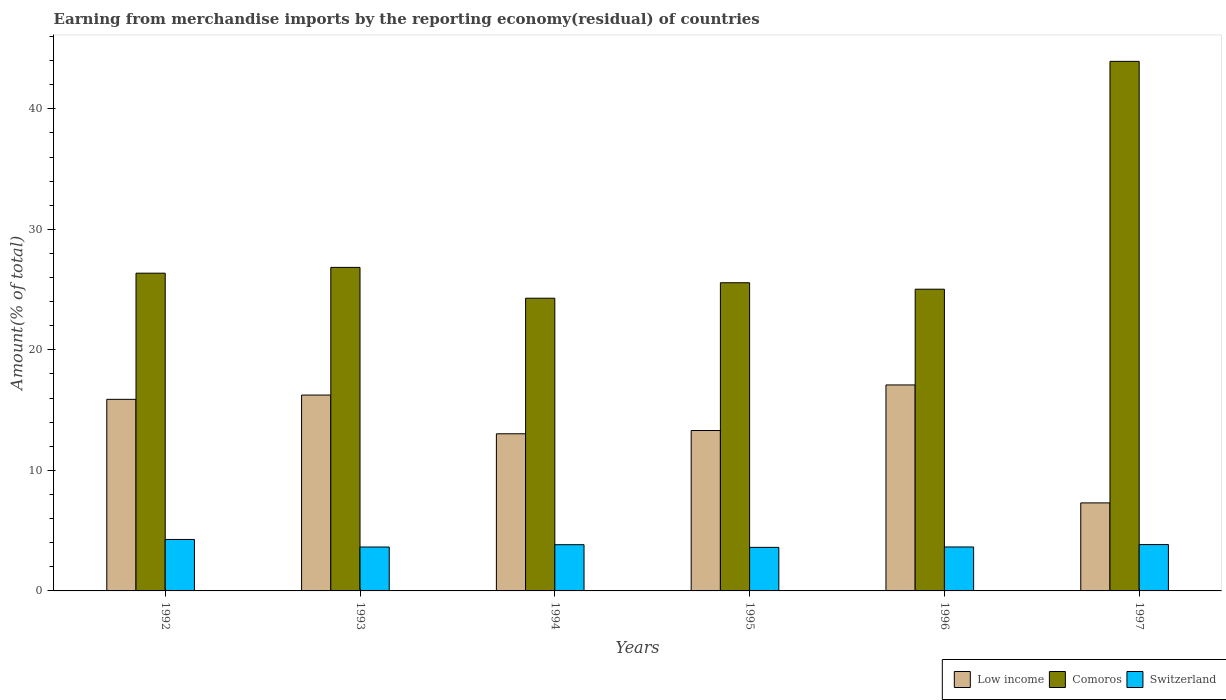Are the number of bars per tick equal to the number of legend labels?
Your answer should be compact. Yes. Are the number of bars on each tick of the X-axis equal?
Your answer should be compact. Yes. How many bars are there on the 2nd tick from the right?
Give a very brief answer. 3. In how many cases, is the number of bars for a given year not equal to the number of legend labels?
Your answer should be very brief. 0. What is the percentage of amount earned from merchandise imports in Switzerland in 1997?
Provide a succinct answer. 3.85. Across all years, what is the maximum percentage of amount earned from merchandise imports in Comoros?
Give a very brief answer. 43.94. Across all years, what is the minimum percentage of amount earned from merchandise imports in Comoros?
Your answer should be very brief. 24.29. In which year was the percentage of amount earned from merchandise imports in Low income minimum?
Provide a succinct answer. 1997. What is the total percentage of amount earned from merchandise imports in Switzerland in the graph?
Your answer should be compact. 22.86. What is the difference between the percentage of amount earned from merchandise imports in Switzerland in 1993 and that in 1995?
Your answer should be compact. 0.03. What is the difference between the percentage of amount earned from merchandise imports in Low income in 1993 and the percentage of amount earned from merchandise imports in Comoros in 1995?
Your answer should be very brief. -9.32. What is the average percentage of amount earned from merchandise imports in Low income per year?
Offer a very short reply. 13.81. In the year 1997, what is the difference between the percentage of amount earned from merchandise imports in Comoros and percentage of amount earned from merchandise imports in Switzerland?
Offer a terse response. 40.09. In how many years, is the percentage of amount earned from merchandise imports in Comoros greater than 34 %?
Your answer should be very brief. 1. What is the ratio of the percentage of amount earned from merchandise imports in Low income in 1996 to that in 1997?
Your answer should be very brief. 2.34. Is the difference between the percentage of amount earned from merchandise imports in Comoros in 1993 and 1997 greater than the difference between the percentage of amount earned from merchandise imports in Switzerland in 1993 and 1997?
Ensure brevity in your answer.  No. What is the difference between the highest and the second highest percentage of amount earned from merchandise imports in Low income?
Offer a terse response. 0.84. What is the difference between the highest and the lowest percentage of amount earned from merchandise imports in Comoros?
Make the answer very short. 19.65. In how many years, is the percentage of amount earned from merchandise imports in Comoros greater than the average percentage of amount earned from merchandise imports in Comoros taken over all years?
Make the answer very short. 1. What does the 2nd bar from the left in 1996 represents?
Give a very brief answer. Comoros. What does the 1st bar from the right in 1992 represents?
Your answer should be very brief. Switzerland. What is the difference between two consecutive major ticks on the Y-axis?
Offer a very short reply. 10. Does the graph contain any zero values?
Your response must be concise. No. How many legend labels are there?
Ensure brevity in your answer.  3. What is the title of the graph?
Ensure brevity in your answer.  Earning from merchandise imports by the reporting economy(residual) of countries. What is the label or title of the Y-axis?
Offer a very short reply. Amount(% of total). What is the Amount(% of total) in Low income in 1992?
Ensure brevity in your answer.  15.9. What is the Amount(% of total) in Comoros in 1992?
Your answer should be very brief. 26.36. What is the Amount(% of total) in Switzerland in 1992?
Make the answer very short. 4.27. What is the Amount(% of total) of Low income in 1993?
Keep it short and to the point. 16.25. What is the Amount(% of total) in Comoros in 1993?
Make the answer very short. 26.85. What is the Amount(% of total) of Switzerland in 1993?
Give a very brief answer. 3.64. What is the Amount(% of total) in Low income in 1994?
Offer a very short reply. 13.04. What is the Amount(% of total) of Comoros in 1994?
Your response must be concise. 24.29. What is the Amount(% of total) in Switzerland in 1994?
Make the answer very short. 3.83. What is the Amount(% of total) of Low income in 1995?
Offer a terse response. 13.31. What is the Amount(% of total) in Comoros in 1995?
Your answer should be very brief. 25.57. What is the Amount(% of total) of Switzerland in 1995?
Your response must be concise. 3.61. What is the Amount(% of total) in Low income in 1996?
Offer a very short reply. 17.09. What is the Amount(% of total) of Comoros in 1996?
Keep it short and to the point. 25.03. What is the Amount(% of total) in Switzerland in 1996?
Make the answer very short. 3.65. What is the Amount(% of total) in Low income in 1997?
Give a very brief answer. 7.3. What is the Amount(% of total) in Comoros in 1997?
Provide a succinct answer. 43.94. What is the Amount(% of total) in Switzerland in 1997?
Provide a short and direct response. 3.85. Across all years, what is the maximum Amount(% of total) of Low income?
Offer a terse response. 17.09. Across all years, what is the maximum Amount(% of total) of Comoros?
Your answer should be very brief. 43.94. Across all years, what is the maximum Amount(% of total) of Switzerland?
Your answer should be compact. 4.27. Across all years, what is the minimum Amount(% of total) of Low income?
Keep it short and to the point. 7.3. Across all years, what is the minimum Amount(% of total) of Comoros?
Your response must be concise. 24.29. Across all years, what is the minimum Amount(% of total) in Switzerland?
Offer a very short reply. 3.61. What is the total Amount(% of total) in Low income in the graph?
Provide a short and direct response. 82.89. What is the total Amount(% of total) of Comoros in the graph?
Your answer should be compact. 172.04. What is the total Amount(% of total) in Switzerland in the graph?
Your response must be concise. 22.86. What is the difference between the Amount(% of total) in Low income in 1992 and that in 1993?
Offer a terse response. -0.35. What is the difference between the Amount(% of total) of Comoros in 1992 and that in 1993?
Provide a short and direct response. -0.48. What is the difference between the Amount(% of total) in Switzerland in 1992 and that in 1993?
Offer a very short reply. 0.63. What is the difference between the Amount(% of total) of Low income in 1992 and that in 1994?
Your response must be concise. 2.86. What is the difference between the Amount(% of total) of Comoros in 1992 and that in 1994?
Offer a terse response. 2.08. What is the difference between the Amount(% of total) in Switzerland in 1992 and that in 1994?
Your response must be concise. 0.43. What is the difference between the Amount(% of total) in Low income in 1992 and that in 1995?
Give a very brief answer. 2.59. What is the difference between the Amount(% of total) in Comoros in 1992 and that in 1995?
Make the answer very short. 0.79. What is the difference between the Amount(% of total) of Switzerland in 1992 and that in 1995?
Offer a very short reply. 0.66. What is the difference between the Amount(% of total) in Low income in 1992 and that in 1996?
Your answer should be very brief. -1.19. What is the difference between the Amount(% of total) in Comoros in 1992 and that in 1996?
Ensure brevity in your answer.  1.33. What is the difference between the Amount(% of total) in Switzerland in 1992 and that in 1996?
Keep it short and to the point. 0.62. What is the difference between the Amount(% of total) in Low income in 1992 and that in 1997?
Your answer should be compact. 8.59. What is the difference between the Amount(% of total) of Comoros in 1992 and that in 1997?
Keep it short and to the point. -17.58. What is the difference between the Amount(% of total) of Switzerland in 1992 and that in 1997?
Offer a terse response. 0.42. What is the difference between the Amount(% of total) of Low income in 1993 and that in 1994?
Provide a succinct answer. 3.21. What is the difference between the Amount(% of total) in Comoros in 1993 and that in 1994?
Make the answer very short. 2.56. What is the difference between the Amount(% of total) in Switzerland in 1993 and that in 1994?
Your answer should be compact. -0.19. What is the difference between the Amount(% of total) in Low income in 1993 and that in 1995?
Offer a very short reply. 2.94. What is the difference between the Amount(% of total) of Comoros in 1993 and that in 1995?
Provide a succinct answer. 1.27. What is the difference between the Amount(% of total) in Switzerland in 1993 and that in 1995?
Make the answer very short. 0.03. What is the difference between the Amount(% of total) of Low income in 1993 and that in 1996?
Keep it short and to the point. -0.84. What is the difference between the Amount(% of total) of Comoros in 1993 and that in 1996?
Your response must be concise. 1.81. What is the difference between the Amount(% of total) in Switzerland in 1993 and that in 1996?
Keep it short and to the point. -0. What is the difference between the Amount(% of total) of Low income in 1993 and that in 1997?
Keep it short and to the point. 8.95. What is the difference between the Amount(% of total) in Comoros in 1993 and that in 1997?
Offer a very short reply. -17.09. What is the difference between the Amount(% of total) in Switzerland in 1993 and that in 1997?
Ensure brevity in your answer.  -0.2. What is the difference between the Amount(% of total) in Low income in 1994 and that in 1995?
Make the answer very short. -0.27. What is the difference between the Amount(% of total) in Comoros in 1994 and that in 1995?
Give a very brief answer. -1.28. What is the difference between the Amount(% of total) in Switzerland in 1994 and that in 1995?
Your answer should be compact. 0.22. What is the difference between the Amount(% of total) of Low income in 1994 and that in 1996?
Provide a succinct answer. -4.05. What is the difference between the Amount(% of total) of Comoros in 1994 and that in 1996?
Offer a terse response. -0.75. What is the difference between the Amount(% of total) in Switzerland in 1994 and that in 1996?
Offer a very short reply. 0.19. What is the difference between the Amount(% of total) of Low income in 1994 and that in 1997?
Give a very brief answer. 5.73. What is the difference between the Amount(% of total) in Comoros in 1994 and that in 1997?
Offer a terse response. -19.65. What is the difference between the Amount(% of total) of Switzerland in 1994 and that in 1997?
Your answer should be compact. -0.01. What is the difference between the Amount(% of total) in Low income in 1995 and that in 1996?
Provide a succinct answer. -3.78. What is the difference between the Amount(% of total) of Comoros in 1995 and that in 1996?
Your answer should be compact. 0.54. What is the difference between the Amount(% of total) in Switzerland in 1995 and that in 1996?
Offer a very short reply. -0.03. What is the difference between the Amount(% of total) in Low income in 1995 and that in 1997?
Make the answer very short. 6.01. What is the difference between the Amount(% of total) in Comoros in 1995 and that in 1997?
Your response must be concise. -18.37. What is the difference between the Amount(% of total) of Switzerland in 1995 and that in 1997?
Provide a short and direct response. -0.23. What is the difference between the Amount(% of total) of Low income in 1996 and that in 1997?
Your answer should be compact. 9.79. What is the difference between the Amount(% of total) of Comoros in 1996 and that in 1997?
Provide a short and direct response. -18.9. What is the difference between the Amount(% of total) in Switzerland in 1996 and that in 1997?
Your response must be concise. -0.2. What is the difference between the Amount(% of total) in Low income in 1992 and the Amount(% of total) in Comoros in 1993?
Your answer should be very brief. -10.95. What is the difference between the Amount(% of total) of Low income in 1992 and the Amount(% of total) of Switzerland in 1993?
Your answer should be very brief. 12.25. What is the difference between the Amount(% of total) in Comoros in 1992 and the Amount(% of total) in Switzerland in 1993?
Offer a terse response. 22.72. What is the difference between the Amount(% of total) of Low income in 1992 and the Amount(% of total) of Comoros in 1994?
Your response must be concise. -8.39. What is the difference between the Amount(% of total) of Low income in 1992 and the Amount(% of total) of Switzerland in 1994?
Provide a short and direct response. 12.06. What is the difference between the Amount(% of total) of Comoros in 1992 and the Amount(% of total) of Switzerland in 1994?
Your answer should be very brief. 22.53. What is the difference between the Amount(% of total) in Low income in 1992 and the Amount(% of total) in Comoros in 1995?
Your response must be concise. -9.67. What is the difference between the Amount(% of total) of Low income in 1992 and the Amount(% of total) of Switzerland in 1995?
Your answer should be compact. 12.28. What is the difference between the Amount(% of total) in Comoros in 1992 and the Amount(% of total) in Switzerland in 1995?
Offer a terse response. 22.75. What is the difference between the Amount(% of total) of Low income in 1992 and the Amount(% of total) of Comoros in 1996?
Make the answer very short. -9.14. What is the difference between the Amount(% of total) in Low income in 1992 and the Amount(% of total) in Switzerland in 1996?
Make the answer very short. 12.25. What is the difference between the Amount(% of total) of Comoros in 1992 and the Amount(% of total) of Switzerland in 1996?
Your answer should be compact. 22.72. What is the difference between the Amount(% of total) in Low income in 1992 and the Amount(% of total) in Comoros in 1997?
Ensure brevity in your answer.  -28.04. What is the difference between the Amount(% of total) in Low income in 1992 and the Amount(% of total) in Switzerland in 1997?
Offer a very short reply. 12.05. What is the difference between the Amount(% of total) in Comoros in 1992 and the Amount(% of total) in Switzerland in 1997?
Offer a very short reply. 22.52. What is the difference between the Amount(% of total) in Low income in 1993 and the Amount(% of total) in Comoros in 1994?
Provide a short and direct response. -8.04. What is the difference between the Amount(% of total) of Low income in 1993 and the Amount(% of total) of Switzerland in 1994?
Your answer should be very brief. 12.42. What is the difference between the Amount(% of total) in Comoros in 1993 and the Amount(% of total) in Switzerland in 1994?
Give a very brief answer. 23.01. What is the difference between the Amount(% of total) in Low income in 1993 and the Amount(% of total) in Comoros in 1995?
Give a very brief answer. -9.32. What is the difference between the Amount(% of total) of Low income in 1993 and the Amount(% of total) of Switzerland in 1995?
Your answer should be very brief. 12.64. What is the difference between the Amount(% of total) of Comoros in 1993 and the Amount(% of total) of Switzerland in 1995?
Keep it short and to the point. 23.23. What is the difference between the Amount(% of total) in Low income in 1993 and the Amount(% of total) in Comoros in 1996?
Your response must be concise. -8.78. What is the difference between the Amount(% of total) in Low income in 1993 and the Amount(% of total) in Switzerland in 1996?
Your answer should be compact. 12.6. What is the difference between the Amount(% of total) of Comoros in 1993 and the Amount(% of total) of Switzerland in 1996?
Ensure brevity in your answer.  23.2. What is the difference between the Amount(% of total) in Low income in 1993 and the Amount(% of total) in Comoros in 1997?
Your answer should be very brief. -27.69. What is the difference between the Amount(% of total) of Low income in 1993 and the Amount(% of total) of Switzerland in 1997?
Provide a short and direct response. 12.41. What is the difference between the Amount(% of total) in Comoros in 1993 and the Amount(% of total) in Switzerland in 1997?
Give a very brief answer. 23. What is the difference between the Amount(% of total) of Low income in 1994 and the Amount(% of total) of Comoros in 1995?
Keep it short and to the point. -12.53. What is the difference between the Amount(% of total) in Low income in 1994 and the Amount(% of total) in Switzerland in 1995?
Offer a terse response. 9.42. What is the difference between the Amount(% of total) of Comoros in 1994 and the Amount(% of total) of Switzerland in 1995?
Provide a succinct answer. 20.67. What is the difference between the Amount(% of total) in Low income in 1994 and the Amount(% of total) in Comoros in 1996?
Give a very brief answer. -12. What is the difference between the Amount(% of total) of Low income in 1994 and the Amount(% of total) of Switzerland in 1996?
Your answer should be very brief. 9.39. What is the difference between the Amount(% of total) of Comoros in 1994 and the Amount(% of total) of Switzerland in 1996?
Offer a very short reply. 20.64. What is the difference between the Amount(% of total) in Low income in 1994 and the Amount(% of total) in Comoros in 1997?
Ensure brevity in your answer.  -30.9. What is the difference between the Amount(% of total) in Low income in 1994 and the Amount(% of total) in Switzerland in 1997?
Make the answer very short. 9.19. What is the difference between the Amount(% of total) in Comoros in 1994 and the Amount(% of total) in Switzerland in 1997?
Offer a terse response. 20.44. What is the difference between the Amount(% of total) in Low income in 1995 and the Amount(% of total) in Comoros in 1996?
Offer a terse response. -11.73. What is the difference between the Amount(% of total) in Low income in 1995 and the Amount(% of total) in Switzerland in 1996?
Provide a short and direct response. 9.66. What is the difference between the Amount(% of total) in Comoros in 1995 and the Amount(% of total) in Switzerland in 1996?
Make the answer very short. 21.92. What is the difference between the Amount(% of total) in Low income in 1995 and the Amount(% of total) in Comoros in 1997?
Your response must be concise. -30.63. What is the difference between the Amount(% of total) in Low income in 1995 and the Amount(% of total) in Switzerland in 1997?
Keep it short and to the point. 9.46. What is the difference between the Amount(% of total) of Comoros in 1995 and the Amount(% of total) of Switzerland in 1997?
Provide a short and direct response. 21.72. What is the difference between the Amount(% of total) in Low income in 1996 and the Amount(% of total) in Comoros in 1997?
Provide a succinct answer. -26.85. What is the difference between the Amount(% of total) of Low income in 1996 and the Amount(% of total) of Switzerland in 1997?
Keep it short and to the point. 13.24. What is the difference between the Amount(% of total) of Comoros in 1996 and the Amount(% of total) of Switzerland in 1997?
Give a very brief answer. 21.19. What is the average Amount(% of total) of Low income per year?
Your response must be concise. 13.81. What is the average Amount(% of total) of Comoros per year?
Keep it short and to the point. 28.67. What is the average Amount(% of total) of Switzerland per year?
Your response must be concise. 3.81. In the year 1992, what is the difference between the Amount(% of total) in Low income and Amount(% of total) in Comoros?
Give a very brief answer. -10.47. In the year 1992, what is the difference between the Amount(% of total) of Low income and Amount(% of total) of Switzerland?
Keep it short and to the point. 11.63. In the year 1992, what is the difference between the Amount(% of total) in Comoros and Amount(% of total) in Switzerland?
Offer a very short reply. 22.09. In the year 1993, what is the difference between the Amount(% of total) in Low income and Amount(% of total) in Comoros?
Your response must be concise. -10.59. In the year 1993, what is the difference between the Amount(% of total) of Low income and Amount(% of total) of Switzerland?
Provide a short and direct response. 12.61. In the year 1993, what is the difference between the Amount(% of total) of Comoros and Amount(% of total) of Switzerland?
Keep it short and to the point. 23.2. In the year 1994, what is the difference between the Amount(% of total) of Low income and Amount(% of total) of Comoros?
Make the answer very short. -11.25. In the year 1994, what is the difference between the Amount(% of total) in Low income and Amount(% of total) in Switzerland?
Give a very brief answer. 9.2. In the year 1994, what is the difference between the Amount(% of total) of Comoros and Amount(% of total) of Switzerland?
Keep it short and to the point. 20.45. In the year 1995, what is the difference between the Amount(% of total) of Low income and Amount(% of total) of Comoros?
Your answer should be very brief. -12.26. In the year 1995, what is the difference between the Amount(% of total) of Low income and Amount(% of total) of Switzerland?
Provide a succinct answer. 9.7. In the year 1995, what is the difference between the Amount(% of total) in Comoros and Amount(% of total) in Switzerland?
Keep it short and to the point. 21.96. In the year 1996, what is the difference between the Amount(% of total) of Low income and Amount(% of total) of Comoros?
Provide a succinct answer. -7.94. In the year 1996, what is the difference between the Amount(% of total) of Low income and Amount(% of total) of Switzerland?
Your answer should be compact. 13.44. In the year 1996, what is the difference between the Amount(% of total) in Comoros and Amount(% of total) in Switzerland?
Your answer should be compact. 21.39. In the year 1997, what is the difference between the Amount(% of total) in Low income and Amount(% of total) in Comoros?
Your response must be concise. -36.64. In the year 1997, what is the difference between the Amount(% of total) of Low income and Amount(% of total) of Switzerland?
Give a very brief answer. 3.46. In the year 1997, what is the difference between the Amount(% of total) in Comoros and Amount(% of total) in Switzerland?
Keep it short and to the point. 40.09. What is the ratio of the Amount(% of total) of Low income in 1992 to that in 1993?
Ensure brevity in your answer.  0.98. What is the ratio of the Amount(% of total) of Comoros in 1992 to that in 1993?
Your answer should be compact. 0.98. What is the ratio of the Amount(% of total) in Switzerland in 1992 to that in 1993?
Offer a terse response. 1.17. What is the ratio of the Amount(% of total) in Low income in 1992 to that in 1994?
Give a very brief answer. 1.22. What is the ratio of the Amount(% of total) in Comoros in 1992 to that in 1994?
Your answer should be very brief. 1.09. What is the ratio of the Amount(% of total) of Switzerland in 1992 to that in 1994?
Provide a short and direct response. 1.11. What is the ratio of the Amount(% of total) in Low income in 1992 to that in 1995?
Provide a short and direct response. 1.19. What is the ratio of the Amount(% of total) of Comoros in 1992 to that in 1995?
Keep it short and to the point. 1.03. What is the ratio of the Amount(% of total) in Switzerland in 1992 to that in 1995?
Provide a succinct answer. 1.18. What is the ratio of the Amount(% of total) of Low income in 1992 to that in 1996?
Offer a very short reply. 0.93. What is the ratio of the Amount(% of total) of Comoros in 1992 to that in 1996?
Your answer should be compact. 1.05. What is the ratio of the Amount(% of total) of Switzerland in 1992 to that in 1996?
Provide a succinct answer. 1.17. What is the ratio of the Amount(% of total) in Low income in 1992 to that in 1997?
Your answer should be compact. 2.18. What is the ratio of the Amount(% of total) of Comoros in 1992 to that in 1997?
Provide a succinct answer. 0.6. What is the ratio of the Amount(% of total) of Switzerland in 1992 to that in 1997?
Offer a very short reply. 1.11. What is the ratio of the Amount(% of total) of Low income in 1993 to that in 1994?
Give a very brief answer. 1.25. What is the ratio of the Amount(% of total) of Comoros in 1993 to that in 1994?
Your response must be concise. 1.11. What is the ratio of the Amount(% of total) of Switzerland in 1993 to that in 1994?
Your answer should be compact. 0.95. What is the ratio of the Amount(% of total) of Low income in 1993 to that in 1995?
Your response must be concise. 1.22. What is the ratio of the Amount(% of total) of Comoros in 1993 to that in 1995?
Keep it short and to the point. 1.05. What is the ratio of the Amount(% of total) in Switzerland in 1993 to that in 1995?
Your answer should be very brief. 1.01. What is the ratio of the Amount(% of total) in Low income in 1993 to that in 1996?
Your answer should be very brief. 0.95. What is the ratio of the Amount(% of total) of Comoros in 1993 to that in 1996?
Provide a succinct answer. 1.07. What is the ratio of the Amount(% of total) of Low income in 1993 to that in 1997?
Make the answer very short. 2.23. What is the ratio of the Amount(% of total) of Comoros in 1993 to that in 1997?
Your response must be concise. 0.61. What is the ratio of the Amount(% of total) in Low income in 1994 to that in 1995?
Make the answer very short. 0.98. What is the ratio of the Amount(% of total) in Comoros in 1994 to that in 1995?
Ensure brevity in your answer.  0.95. What is the ratio of the Amount(% of total) of Switzerland in 1994 to that in 1995?
Make the answer very short. 1.06. What is the ratio of the Amount(% of total) of Low income in 1994 to that in 1996?
Make the answer very short. 0.76. What is the ratio of the Amount(% of total) of Comoros in 1994 to that in 1996?
Provide a succinct answer. 0.97. What is the ratio of the Amount(% of total) of Switzerland in 1994 to that in 1996?
Provide a short and direct response. 1.05. What is the ratio of the Amount(% of total) of Low income in 1994 to that in 1997?
Provide a short and direct response. 1.79. What is the ratio of the Amount(% of total) in Comoros in 1994 to that in 1997?
Your answer should be compact. 0.55. What is the ratio of the Amount(% of total) of Low income in 1995 to that in 1996?
Ensure brevity in your answer.  0.78. What is the ratio of the Amount(% of total) in Comoros in 1995 to that in 1996?
Provide a succinct answer. 1.02. What is the ratio of the Amount(% of total) in Switzerland in 1995 to that in 1996?
Give a very brief answer. 0.99. What is the ratio of the Amount(% of total) in Low income in 1995 to that in 1997?
Provide a short and direct response. 1.82. What is the ratio of the Amount(% of total) of Comoros in 1995 to that in 1997?
Your answer should be compact. 0.58. What is the ratio of the Amount(% of total) of Switzerland in 1995 to that in 1997?
Your response must be concise. 0.94. What is the ratio of the Amount(% of total) in Low income in 1996 to that in 1997?
Your answer should be compact. 2.34. What is the ratio of the Amount(% of total) of Comoros in 1996 to that in 1997?
Your answer should be very brief. 0.57. What is the ratio of the Amount(% of total) of Switzerland in 1996 to that in 1997?
Your answer should be very brief. 0.95. What is the difference between the highest and the second highest Amount(% of total) of Low income?
Your response must be concise. 0.84. What is the difference between the highest and the second highest Amount(% of total) in Comoros?
Give a very brief answer. 17.09. What is the difference between the highest and the second highest Amount(% of total) of Switzerland?
Offer a terse response. 0.42. What is the difference between the highest and the lowest Amount(% of total) of Low income?
Ensure brevity in your answer.  9.79. What is the difference between the highest and the lowest Amount(% of total) in Comoros?
Give a very brief answer. 19.65. What is the difference between the highest and the lowest Amount(% of total) of Switzerland?
Your answer should be very brief. 0.66. 